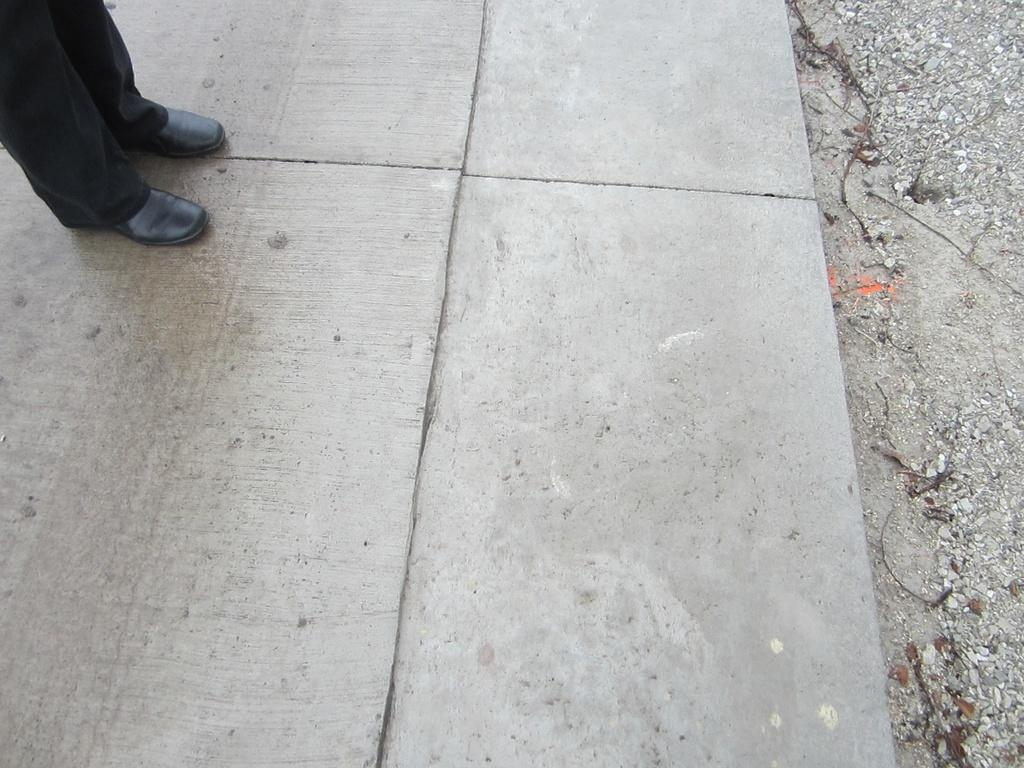Who or what is the main subject in the image? There is a person in the image. What part of the person's body can be seen in the image? The person's legs are visible in the image. What type of footwear is the person wearing? The person is wearing shoes. What is the person standing on or interacting with in the image? There is a surface in the image. What type of natural elements can be seen in the background of the image? Small stones are present in the background of the image. What type of shop can be seen in the background of the image? There is no shop present in the image; it features a person with visible legs, wearing shoes, standing on a surface, with small stones in the background. 